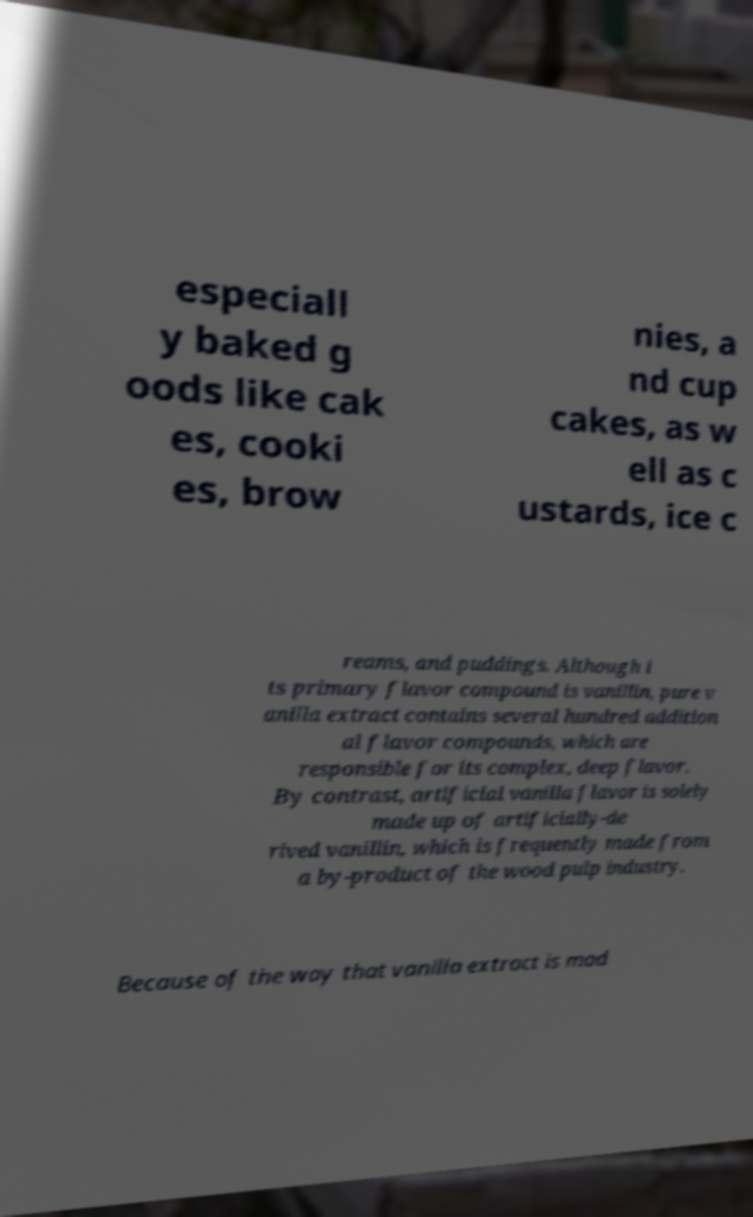Could you extract and type out the text from this image? especiall y baked g oods like cak es, cooki es, brow nies, a nd cup cakes, as w ell as c ustards, ice c reams, and puddings. Although i ts primary flavor compound is vanillin, pure v anilla extract contains several hundred addition al flavor compounds, which are responsible for its complex, deep flavor. By contrast, artificial vanilla flavor is solely made up of artificially-de rived vanillin, which is frequently made from a by-product of the wood pulp industry. Because of the way that vanilla extract is mad 